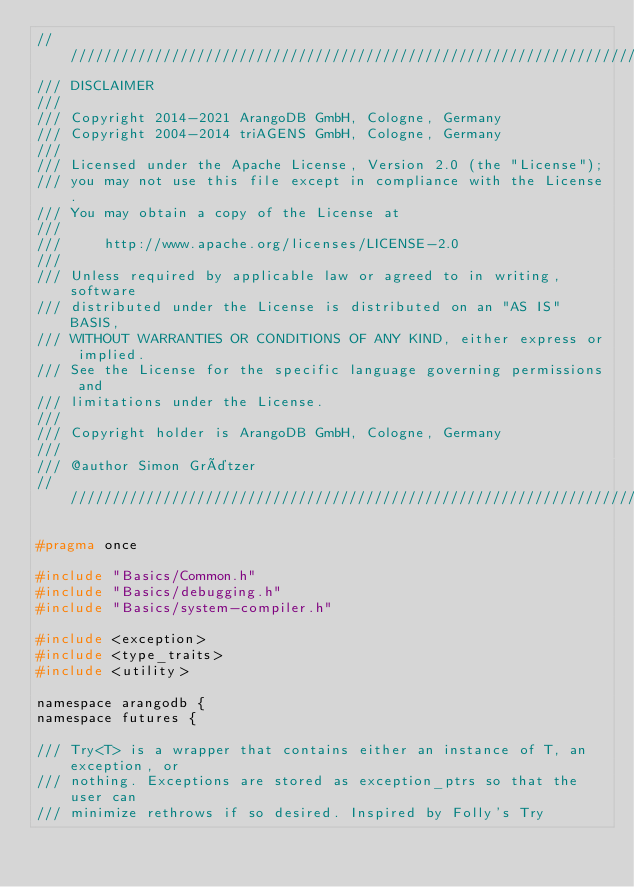<code> <loc_0><loc_0><loc_500><loc_500><_C_>////////////////////////////////////////////////////////////////////////////////
/// DISCLAIMER
///
/// Copyright 2014-2021 ArangoDB GmbH, Cologne, Germany
/// Copyright 2004-2014 triAGENS GmbH, Cologne, Germany
///
/// Licensed under the Apache License, Version 2.0 (the "License");
/// you may not use this file except in compliance with the License.
/// You may obtain a copy of the License at
///
///     http://www.apache.org/licenses/LICENSE-2.0
///
/// Unless required by applicable law or agreed to in writing, software
/// distributed under the License is distributed on an "AS IS" BASIS,
/// WITHOUT WARRANTIES OR CONDITIONS OF ANY KIND, either express or implied.
/// See the License for the specific language governing permissions and
/// limitations under the License.
///
/// Copyright holder is ArangoDB GmbH, Cologne, Germany
///
/// @author Simon Grätzer
////////////////////////////////////////////////////////////////////////////////

#pragma once

#include "Basics/Common.h"
#include "Basics/debugging.h"
#include "Basics/system-compiler.h"

#include <exception>
#include <type_traits>
#include <utility>

namespace arangodb {
namespace futures {

/// Try<T> is a wrapper that contains either an instance of T, an exception, or
/// nothing. Exceptions are stored as exception_ptrs so that the user can
/// minimize rethrows if so desired. Inspired by Folly's Try</code> 